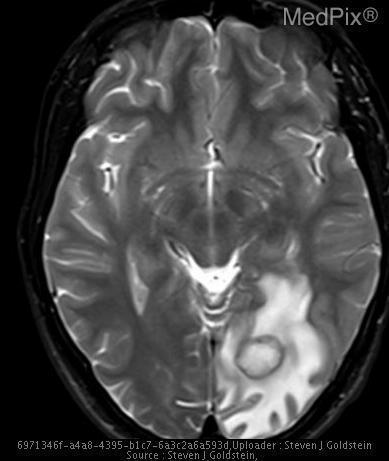Is the lesion ring enhancing?
Concise answer only. Yes. Is the cortex atrophied?
Keep it brief. No. Is there cortical atrophy?
Short answer required. No. Can the white and gray matter be differentiated?
Be succinct. Yes. Is there good gray-white matter differentiation?
Quick response, please. Yes. Where is the lesion located?
Answer briefly. Left occipital lobe. Which lobe is the lesion in?
Give a very brief answer. Left occipital lobe. 